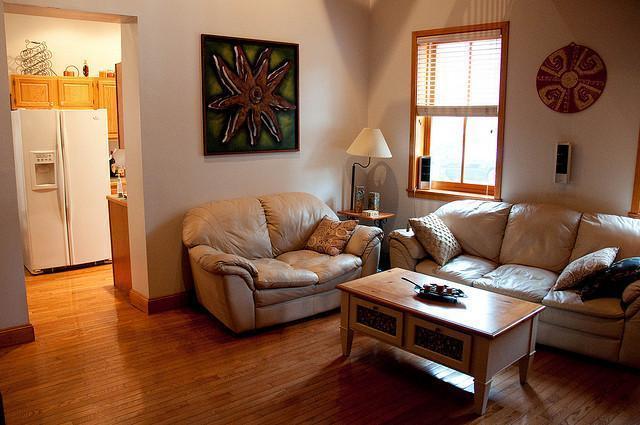How many couches are visible?
Give a very brief answer. 2. How many horses in this picture do not have white feet?
Give a very brief answer. 0. 